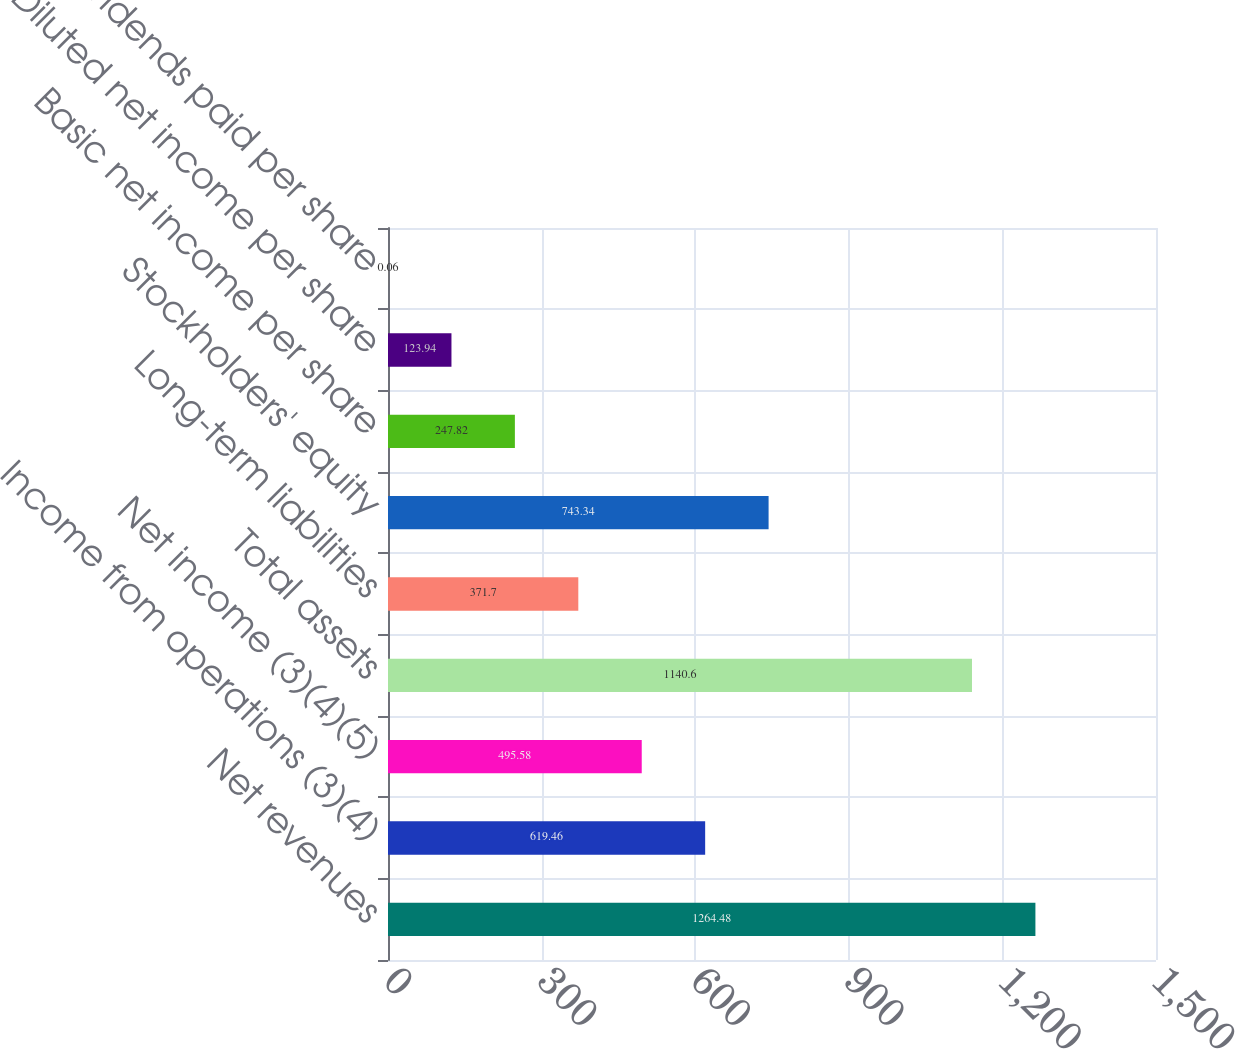Convert chart to OTSL. <chart><loc_0><loc_0><loc_500><loc_500><bar_chart><fcel>Net revenues<fcel>Income from operations (3)(4)<fcel>Net income (3)(4)(5)<fcel>Total assets<fcel>Long-term liabilities<fcel>Stockholders' equity<fcel>Basic net income per share<fcel>Diluted net income per share<fcel>Dividends paid per share<nl><fcel>1264.48<fcel>619.46<fcel>495.58<fcel>1140.6<fcel>371.7<fcel>743.34<fcel>247.82<fcel>123.94<fcel>0.06<nl></chart> 